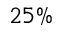Convert formula to latex. <formula><loc_0><loc_0><loc_500><loc_500>2 5 \%</formula> 